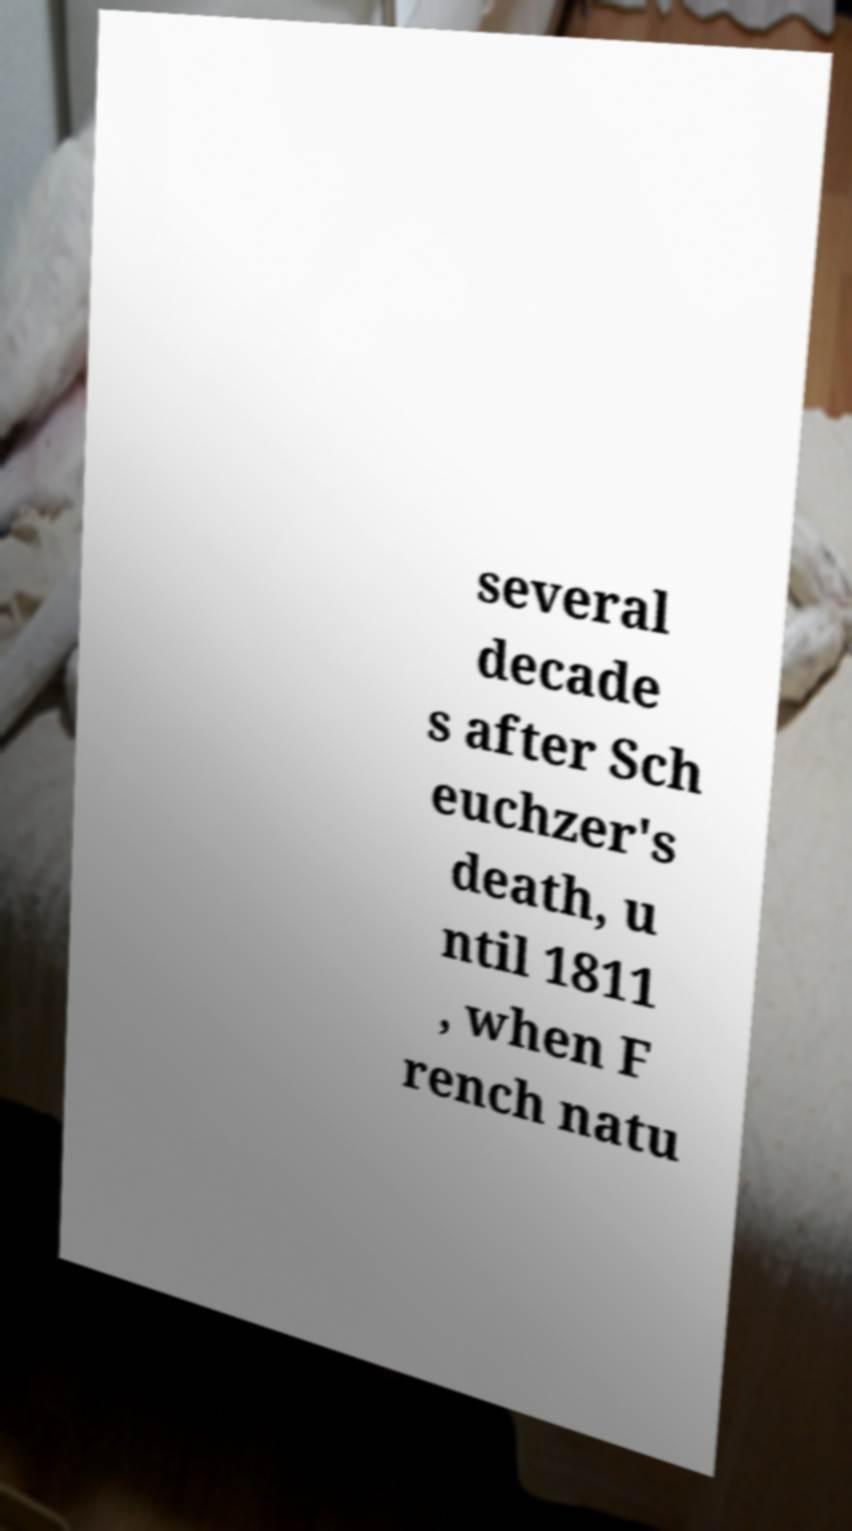Could you assist in decoding the text presented in this image and type it out clearly? several decade s after Sch euchzer's death, u ntil 1811 , when F rench natu 